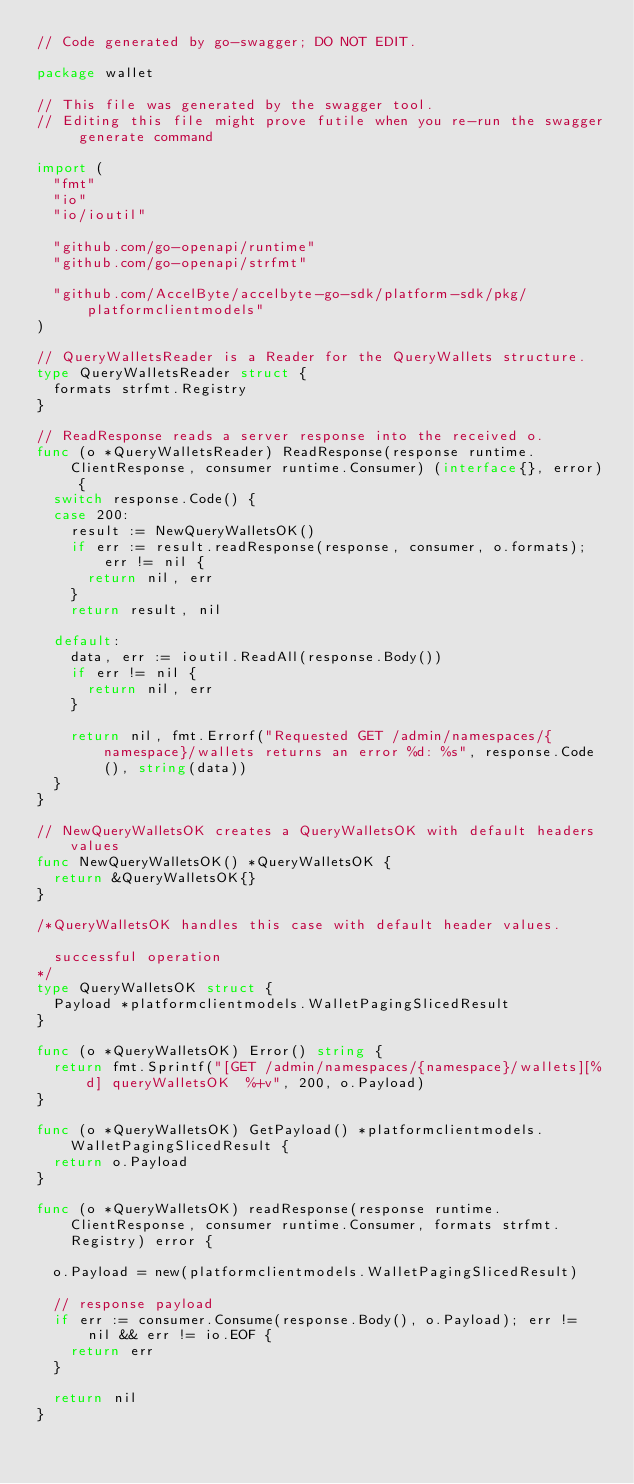Convert code to text. <code><loc_0><loc_0><loc_500><loc_500><_Go_>// Code generated by go-swagger; DO NOT EDIT.

package wallet

// This file was generated by the swagger tool.
// Editing this file might prove futile when you re-run the swagger generate command

import (
	"fmt"
	"io"
	"io/ioutil"

	"github.com/go-openapi/runtime"
	"github.com/go-openapi/strfmt"

	"github.com/AccelByte/accelbyte-go-sdk/platform-sdk/pkg/platformclientmodels"
)

// QueryWalletsReader is a Reader for the QueryWallets structure.
type QueryWalletsReader struct {
	formats strfmt.Registry
}

// ReadResponse reads a server response into the received o.
func (o *QueryWalletsReader) ReadResponse(response runtime.ClientResponse, consumer runtime.Consumer) (interface{}, error) {
	switch response.Code() {
	case 200:
		result := NewQueryWalletsOK()
		if err := result.readResponse(response, consumer, o.formats); err != nil {
			return nil, err
		}
		return result, nil

	default:
		data, err := ioutil.ReadAll(response.Body())
		if err != nil {
			return nil, err
		}

		return nil, fmt.Errorf("Requested GET /admin/namespaces/{namespace}/wallets returns an error %d: %s", response.Code(), string(data))
	}
}

// NewQueryWalletsOK creates a QueryWalletsOK with default headers values
func NewQueryWalletsOK() *QueryWalletsOK {
	return &QueryWalletsOK{}
}

/*QueryWalletsOK handles this case with default header values.

  successful operation
*/
type QueryWalletsOK struct {
	Payload *platformclientmodels.WalletPagingSlicedResult
}

func (o *QueryWalletsOK) Error() string {
	return fmt.Sprintf("[GET /admin/namespaces/{namespace}/wallets][%d] queryWalletsOK  %+v", 200, o.Payload)
}

func (o *QueryWalletsOK) GetPayload() *platformclientmodels.WalletPagingSlicedResult {
	return o.Payload
}

func (o *QueryWalletsOK) readResponse(response runtime.ClientResponse, consumer runtime.Consumer, formats strfmt.Registry) error {

	o.Payload = new(platformclientmodels.WalletPagingSlicedResult)

	// response payload
	if err := consumer.Consume(response.Body(), o.Payload); err != nil && err != io.EOF {
		return err
	}

	return nil
}
</code> 